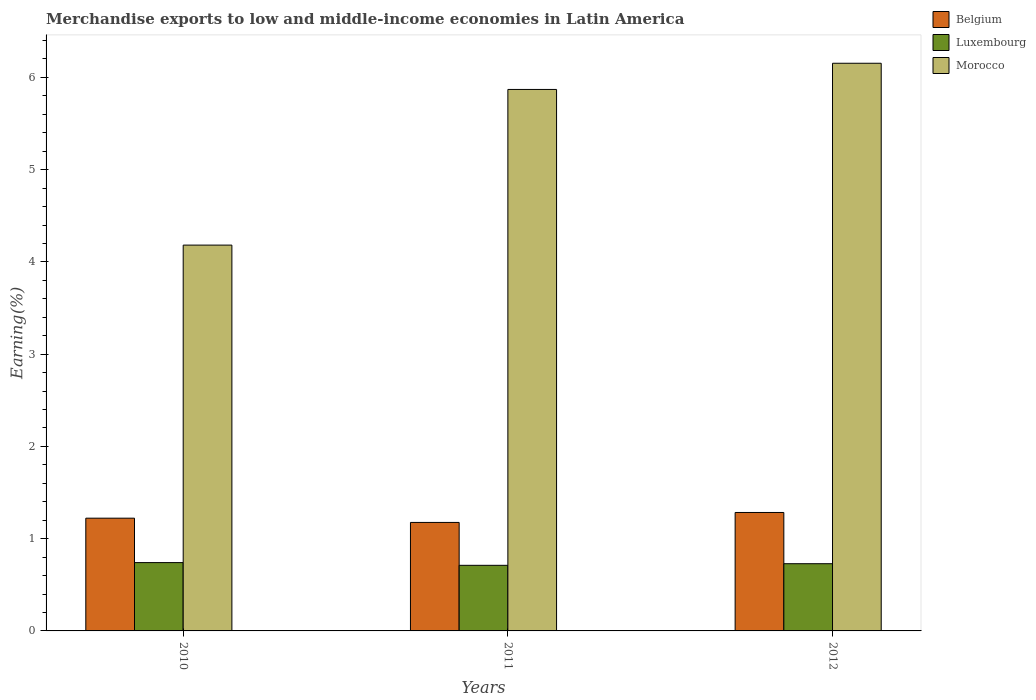How many groups of bars are there?
Provide a short and direct response. 3. Are the number of bars per tick equal to the number of legend labels?
Keep it short and to the point. Yes. Are the number of bars on each tick of the X-axis equal?
Make the answer very short. Yes. How many bars are there on the 3rd tick from the left?
Offer a terse response. 3. How many bars are there on the 2nd tick from the right?
Your answer should be very brief. 3. What is the percentage of amount earned from merchandise exports in Luxembourg in 2012?
Give a very brief answer. 0.73. Across all years, what is the maximum percentage of amount earned from merchandise exports in Belgium?
Keep it short and to the point. 1.28. Across all years, what is the minimum percentage of amount earned from merchandise exports in Belgium?
Offer a terse response. 1.18. In which year was the percentage of amount earned from merchandise exports in Belgium maximum?
Keep it short and to the point. 2012. What is the total percentage of amount earned from merchandise exports in Belgium in the graph?
Your answer should be very brief. 3.68. What is the difference between the percentage of amount earned from merchandise exports in Morocco in 2010 and that in 2012?
Give a very brief answer. -1.97. What is the difference between the percentage of amount earned from merchandise exports in Morocco in 2011 and the percentage of amount earned from merchandise exports in Belgium in 2010?
Your answer should be compact. 4.65. What is the average percentage of amount earned from merchandise exports in Belgium per year?
Your response must be concise. 1.23. In the year 2011, what is the difference between the percentage of amount earned from merchandise exports in Luxembourg and percentage of amount earned from merchandise exports in Morocco?
Your answer should be compact. -5.16. In how many years, is the percentage of amount earned from merchandise exports in Luxembourg greater than 5.4 %?
Make the answer very short. 0. What is the ratio of the percentage of amount earned from merchandise exports in Belgium in 2010 to that in 2011?
Provide a succinct answer. 1.04. Is the percentage of amount earned from merchandise exports in Belgium in 2011 less than that in 2012?
Provide a succinct answer. Yes. What is the difference between the highest and the second highest percentage of amount earned from merchandise exports in Belgium?
Your answer should be compact. 0.06. What is the difference between the highest and the lowest percentage of amount earned from merchandise exports in Morocco?
Ensure brevity in your answer.  1.97. What does the 3rd bar from the left in 2011 represents?
Provide a short and direct response. Morocco. What does the 1st bar from the right in 2012 represents?
Offer a terse response. Morocco. How many years are there in the graph?
Provide a short and direct response. 3. Does the graph contain any zero values?
Offer a terse response. No. Where does the legend appear in the graph?
Your response must be concise. Top right. How many legend labels are there?
Offer a very short reply. 3. How are the legend labels stacked?
Ensure brevity in your answer.  Vertical. What is the title of the graph?
Your response must be concise. Merchandise exports to low and middle-income economies in Latin America. Does "Latvia" appear as one of the legend labels in the graph?
Ensure brevity in your answer.  No. What is the label or title of the X-axis?
Provide a short and direct response. Years. What is the label or title of the Y-axis?
Offer a terse response. Earning(%). What is the Earning(%) in Belgium in 2010?
Ensure brevity in your answer.  1.22. What is the Earning(%) in Luxembourg in 2010?
Provide a succinct answer. 0.74. What is the Earning(%) of Morocco in 2010?
Your answer should be compact. 4.18. What is the Earning(%) of Belgium in 2011?
Offer a very short reply. 1.18. What is the Earning(%) of Luxembourg in 2011?
Provide a short and direct response. 0.71. What is the Earning(%) in Morocco in 2011?
Offer a terse response. 5.87. What is the Earning(%) of Belgium in 2012?
Give a very brief answer. 1.28. What is the Earning(%) in Luxembourg in 2012?
Your answer should be compact. 0.73. What is the Earning(%) in Morocco in 2012?
Make the answer very short. 6.15. Across all years, what is the maximum Earning(%) in Belgium?
Your answer should be very brief. 1.28. Across all years, what is the maximum Earning(%) of Luxembourg?
Your answer should be compact. 0.74. Across all years, what is the maximum Earning(%) of Morocco?
Make the answer very short. 6.15. Across all years, what is the minimum Earning(%) in Belgium?
Your answer should be compact. 1.18. Across all years, what is the minimum Earning(%) of Luxembourg?
Provide a short and direct response. 0.71. Across all years, what is the minimum Earning(%) of Morocco?
Make the answer very short. 4.18. What is the total Earning(%) of Belgium in the graph?
Your answer should be compact. 3.68. What is the total Earning(%) in Luxembourg in the graph?
Your answer should be very brief. 2.18. What is the total Earning(%) in Morocco in the graph?
Your response must be concise. 16.21. What is the difference between the Earning(%) in Belgium in 2010 and that in 2011?
Your answer should be compact. 0.05. What is the difference between the Earning(%) in Luxembourg in 2010 and that in 2011?
Provide a short and direct response. 0.03. What is the difference between the Earning(%) of Morocco in 2010 and that in 2011?
Offer a very short reply. -1.69. What is the difference between the Earning(%) in Belgium in 2010 and that in 2012?
Your response must be concise. -0.06. What is the difference between the Earning(%) of Luxembourg in 2010 and that in 2012?
Give a very brief answer. 0.01. What is the difference between the Earning(%) of Morocco in 2010 and that in 2012?
Your response must be concise. -1.97. What is the difference between the Earning(%) of Belgium in 2011 and that in 2012?
Ensure brevity in your answer.  -0.11. What is the difference between the Earning(%) of Luxembourg in 2011 and that in 2012?
Give a very brief answer. -0.02. What is the difference between the Earning(%) in Morocco in 2011 and that in 2012?
Provide a succinct answer. -0.28. What is the difference between the Earning(%) in Belgium in 2010 and the Earning(%) in Luxembourg in 2011?
Your answer should be very brief. 0.51. What is the difference between the Earning(%) of Belgium in 2010 and the Earning(%) of Morocco in 2011?
Provide a succinct answer. -4.65. What is the difference between the Earning(%) in Luxembourg in 2010 and the Earning(%) in Morocco in 2011?
Give a very brief answer. -5.13. What is the difference between the Earning(%) in Belgium in 2010 and the Earning(%) in Luxembourg in 2012?
Ensure brevity in your answer.  0.49. What is the difference between the Earning(%) of Belgium in 2010 and the Earning(%) of Morocco in 2012?
Offer a very short reply. -4.93. What is the difference between the Earning(%) in Luxembourg in 2010 and the Earning(%) in Morocco in 2012?
Make the answer very short. -5.41. What is the difference between the Earning(%) of Belgium in 2011 and the Earning(%) of Luxembourg in 2012?
Offer a very short reply. 0.45. What is the difference between the Earning(%) in Belgium in 2011 and the Earning(%) in Morocco in 2012?
Your response must be concise. -4.98. What is the difference between the Earning(%) in Luxembourg in 2011 and the Earning(%) in Morocco in 2012?
Make the answer very short. -5.44. What is the average Earning(%) in Belgium per year?
Keep it short and to the point. 1.23. What is the average Earning(%) of Luxembourg per year?
Provide a short and direct response. 0.73. What is the average Earning(%) in Morocco per year?
Give a very brief answer. 5.4. In the year 2010, what is the difference between the Earning(%) in Belgium and Earning(%) in Luxembourg?
Your response must be concise. 0.48. In the year 2010, what is the difference between the Earning(%) of Belgium and Earning(%) of Morocco?
Provide a succinct answer. -2.96. In the year 2010, what is the difference between the Earning(%) in Luxembourg and Earning(%) in Morocco?
Make the answer very short. -3.44. In the year 2011, what is the difference between the Earning(%) of Belgium and Earning(%) of Luxembourg?
Your response must be concise. 0.46. In the year 2011, what is the difference between the Earning(%) of Belgium and Earning(%) of Morocco?
Offer a terse response. -4.69. In the year 2011, what is the difference between the Earning(%) of Luxembourg and Earning(%) of Morocco?
Make the answer very short. -5.16. In the year 2012, what is the difference between the Earning(%) of Belgium and Earning(%) of Luxembourg?
Provide a succinct answer. 0.56. In the year 2012, what is the difference between the Earning(%) of Belgium and Earning(%) of Morocco?
Keep it short and to the point. -4.87. In the year 2012, what is the difference between the Earning(%) of Luxembourg and Earning(%) of Morocco?
Provide a short and direct response. -5.43. What is the ratio of the Earning(%) of Belgium in 2010 to that in 2011?
Your answer should be very brief. 1.04. What is the ratio of the Earning(%) in Luxembourg in 2010 to that in 2011?
Your response must be concise. 1.04. What is the ratio of the Earning(%) in Morocco in 2010 to that in 2011?
Provide a succinct answer. 0.71. What is the ratio of the Earning(%) in Belgium in 2010 to that in 2012?
Offer a very short reply. 0.95. What is the ratio of the Earning(%) in Luxembourg in 2010 to that in 2012?
Offer a very short reply. 1.02. What is the ratio of the Earning(%) in Morocco in 2010 to that in 2012?
Offer a very short reply. 0.68. What is the ratio of the Earning(%) in Belgium in 2011 to that in 2012?
Your answer should be compact. 0.92. What is the ratio of the Earning(%) in Luxembourg in 2011 to that in 2012?
Make the answer very short. 0.98. What is the ratio of the Earning(%) of Morocco in 2011 to that in 2012?
Provide a succinct answer. 0.95. What is the difference between the highest and the second highest Earning(%) of Belgium?
Your response must be concise. 0.06. What is the difference between the highest and the second highest Earning(%) in Luxembourg?
Provide a succinct answer. 0.01. What is the difference between the highest and the second highest Earning(%) in Morocco?
Keep it short and to the point. 0.28. What is the difference between the highest and the lowest Earning(%) of Belgium?
Your response must be concise. 0.11. What is the difference between the highest and the lowest Earning(%) in Luxembourg?
Offer a very short reply. 0.03. What is the difference between the highest and the lowest Earning(%) in Morocco?
Provide a short and direct response. 1.97. 